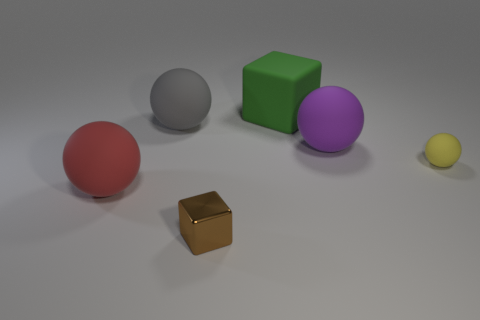Is the number of large spheres in front of the yellow matte thing greater than the number of yellow objects in front of the tiny block?
Your response must be concise. Yes. There is a block that is behind the tiny brown metal cube; what is it made of?
Ensure brevity in your answer.  Rubber. There is a big gray object; does it have the same shape as the tiny object left of the large purple matte sphere?
Give a very brief answer. No. How many brown objects are in front of the matte thing that is on the right side of the big object that is to the right of the large green rubber cube?
Ensure brevity in your answer.  1. There is another small matte object that is the same shape as the gray thing; what is its color?
Offer a very short reply. Yellow. How many spheres are big gray rubber objects or big red rubber objects?
Your answer should be very brief. 2. There is a purple matte object; what shape is it?
Keep it short and to the point. Sphere. There is a tiny yellow rubber thing; are there any gray rubber things behind it?
Your answer should be compact. Yes. Does the gray ball have the same material as the cube that is behind the red object?
Provide a short and direct response. Yes. There is a small object in front of the tiny yellow matte thing; is its shape the same as the red rubber thing?
Offer a terse response. No. 